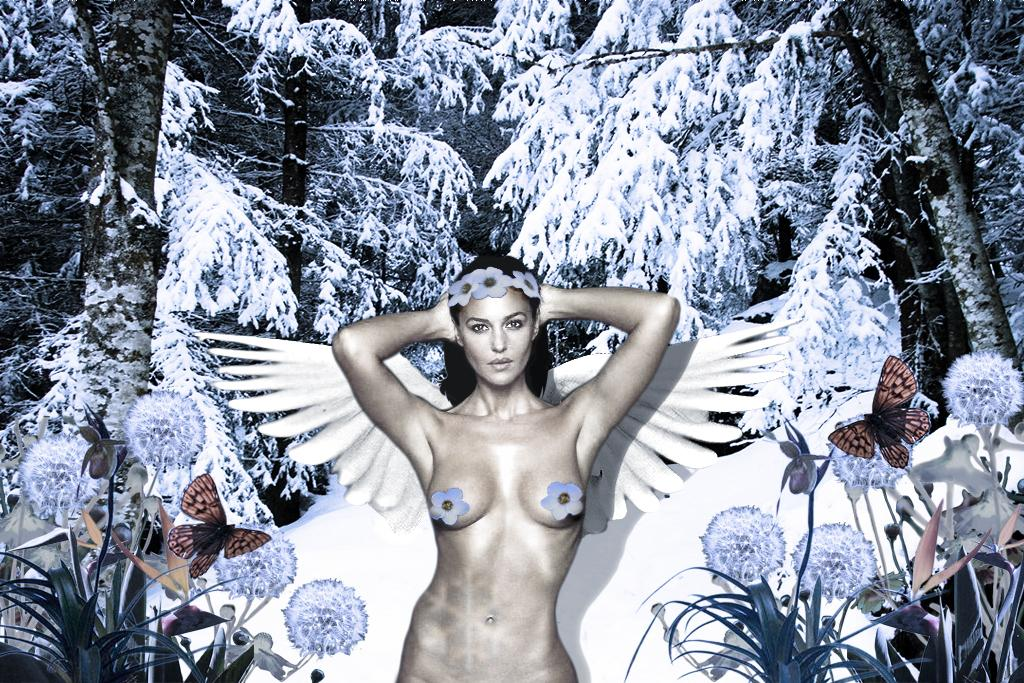How has the image been altered? The image is edited. What is the main subject of the image? There is a nude woman in the image. What type of vegetation can be seen in the image? There are plants, flowers, and trees in the image. What animals are present in the image? There are butterflies in the image. What is the condition of the trees in the image? The trees are fully covered with snow. What is the chance of winning the lottery in the image? There is no reference to a lottery or winning in the image, so it is not possible to determine the chance of winning. 